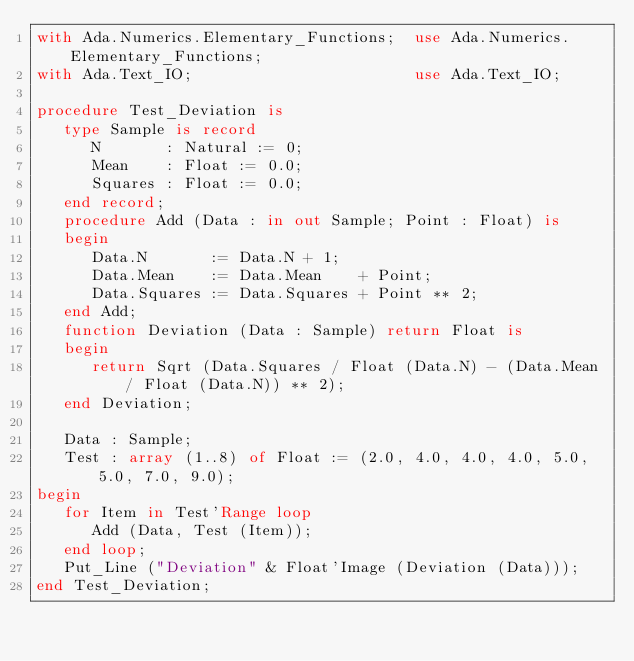Convert code to text. <code><loc_0><loc_0><loc_500><loc_500><_Ada_>with Ada.Numerics.Elementary_Functions;  use Ada.Numerics.Elementary_Functions;
with Ada.Text_IO;                        use Ada.Text_IO;

procedure Test_Deviation is
   type Sample is record
      N       : Natural := 0;
      Mean    : Float := 0.0;
      Squares : Float := 0.0;
   end record;
   procedure Add (Data : in out Sample; Point : Float) is
   begin
      Data.N       := Data.N + 1;
      Data.Mean    := Data.Mean    + Point;
      Data.Squares := Data.Squares + Point ** 2;
   end Add;
   function Deviation (Data : Sample) return Float is
   begin
      return Sqrt (Data.Squares / Float (Data.N) - (Data.Mean / Float (Data.N)) ** 2);
   end Deviation;

   Data : Sample;
   Test : array (1..8) of Float := (2.0, 4.0, 4.0, 4.0, 5.0, 5.0, 7.0, 9.0);
begin
   for Item in Test'Range loop
      Add (Data, Test (Item));
   end loop;
   Put_Line ("Deviation" & Float'Image (Deviation (Data)));
end Test_Deviation;
</code> 